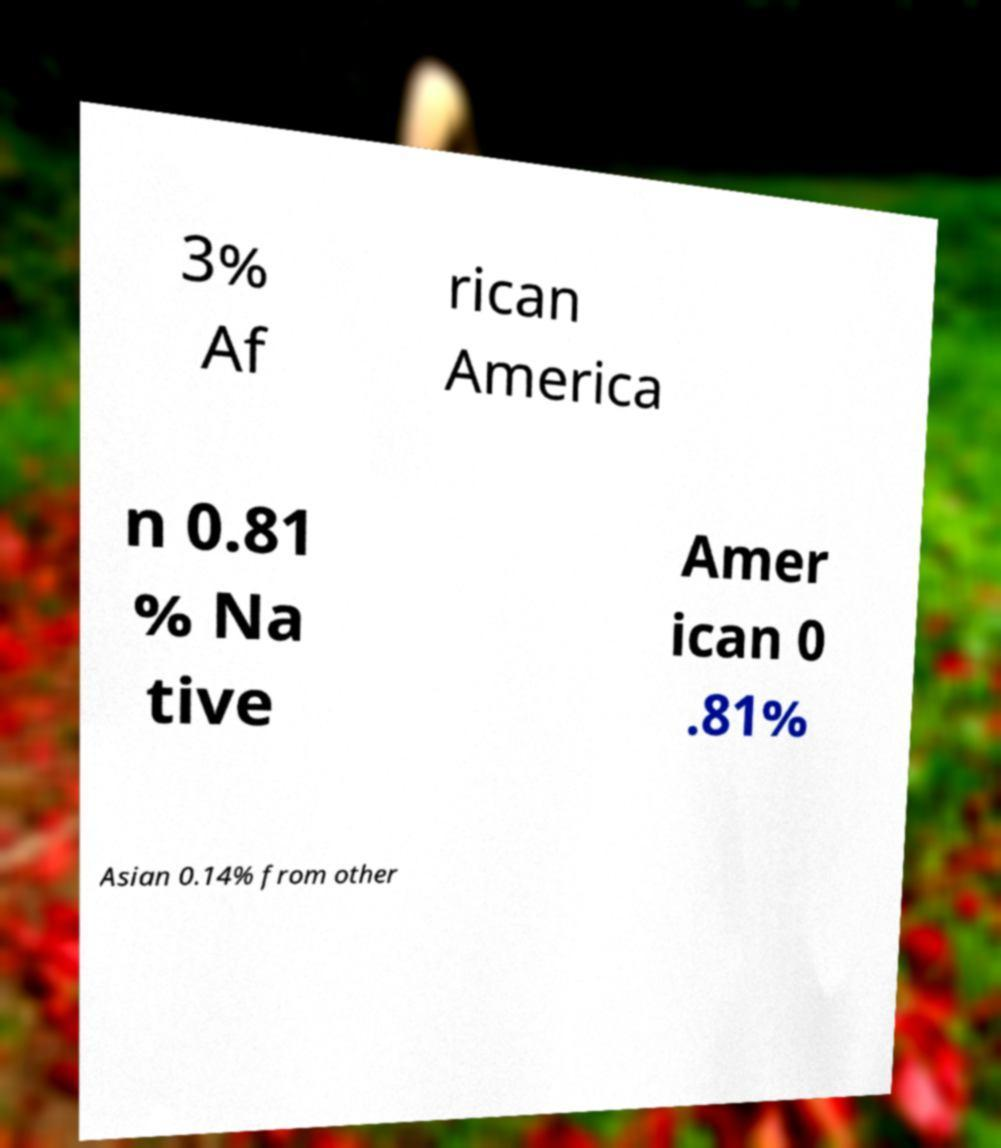Please read and relay the text visible in this image. What does it say? 3% Af rican America n 0.81 % Na tive Amer ican 0 .81% Asian 0.14% from other 